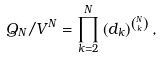Convert formula to latex. <formula><loc_0><loc_0><loc_500><loc_500>Q _ { N } / V ^ { N } = \prod _ { k = 2 } ^ { N } \left ( d _ { k } \right ) ^ { \binom { N } { k } } ,</formula> 